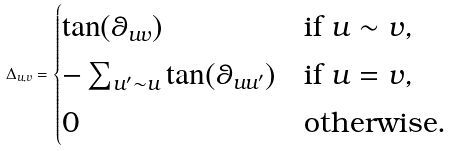Convert formula to latex. <formula><loc_0><loc_0><loc_500><loc_500>\Delta _ { u , v } = \begin{cases} \tan ( \theta _ { u v } ) & \text {if $u\sim v$} , \\ - \sum _ { u ^ { \prime } \sim u } \tan ( \theta _ { u u ^ { \prime } } ) & \text {if $u=v$} , \\ 0 & \text {otherwise} . \end{cases}</formula> 